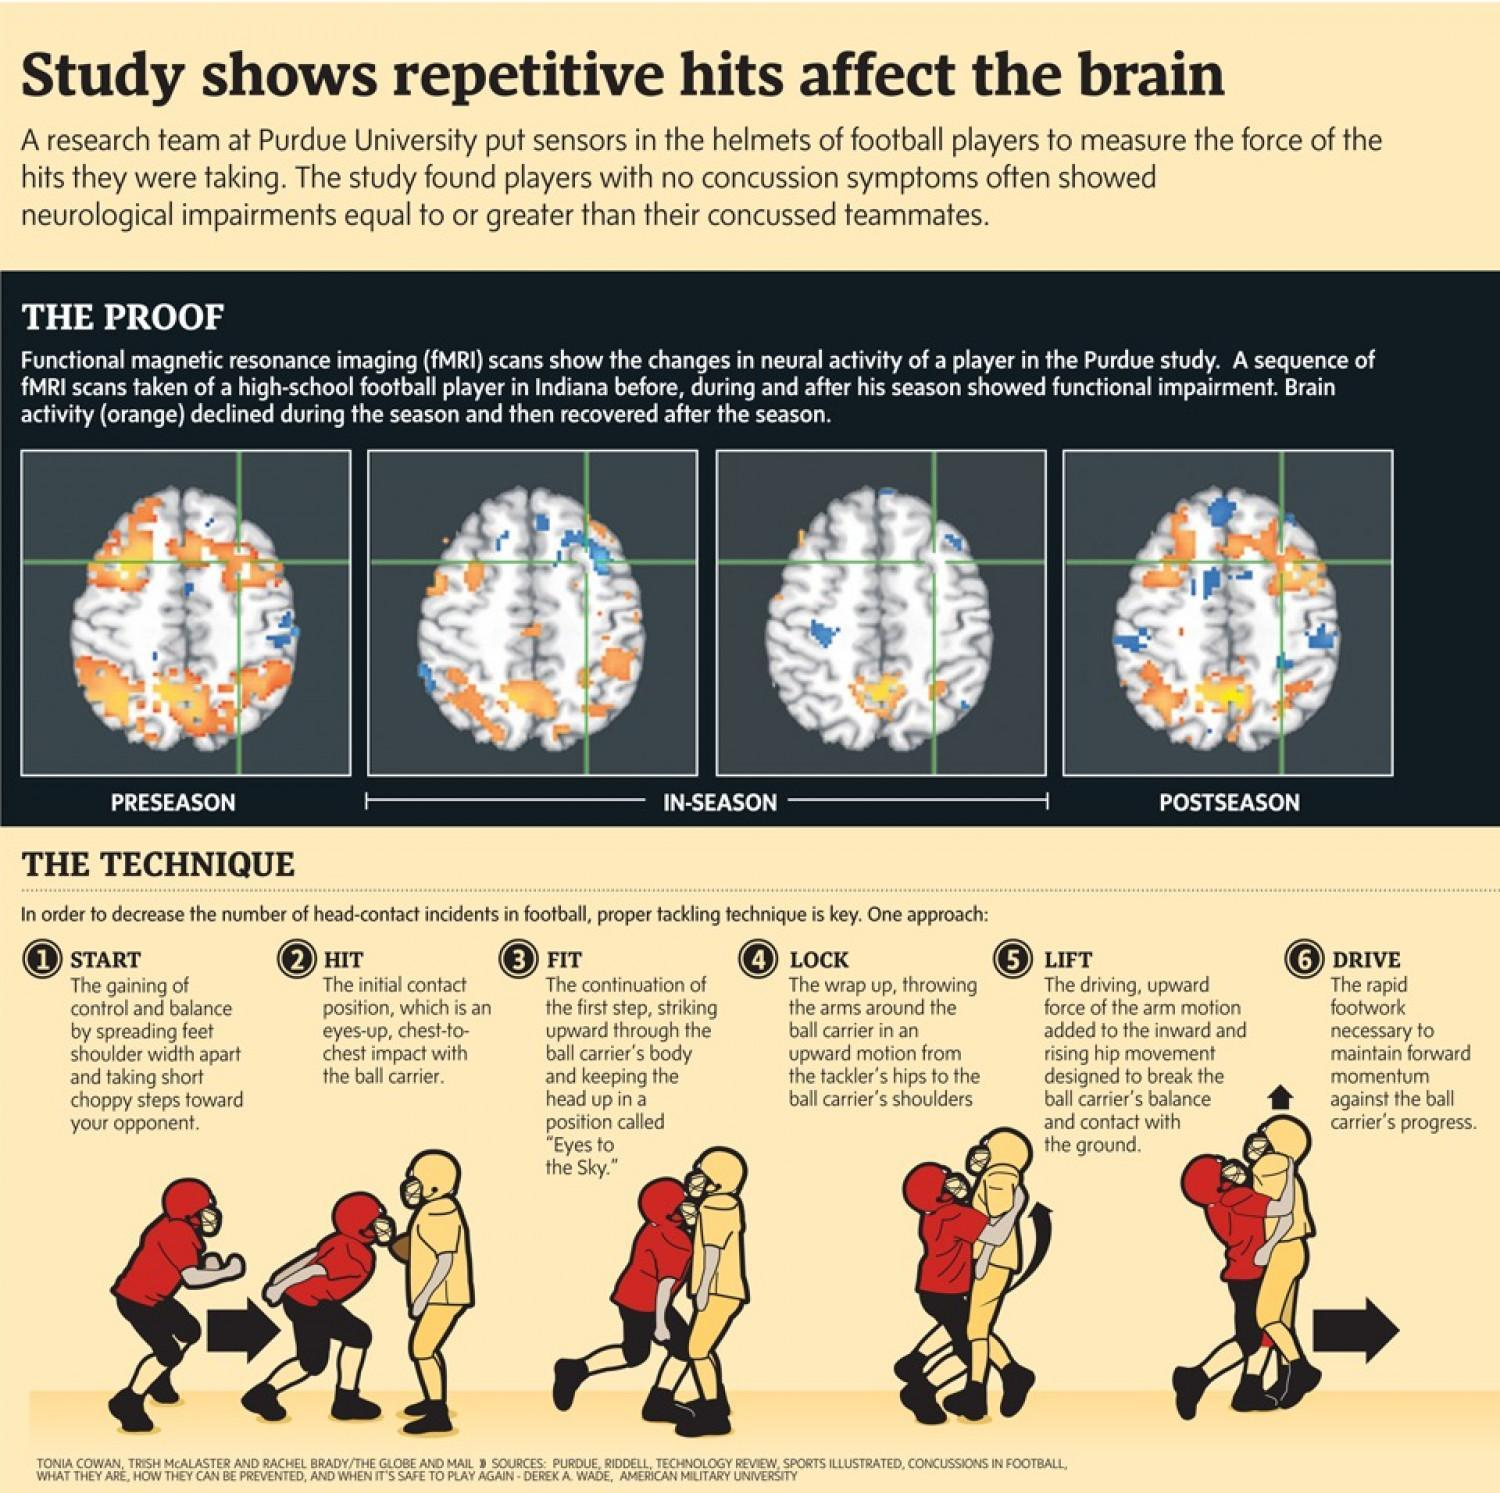How many functional fMRI scan images are shown in this infographic?
Answer the question with a short phrase. 4 